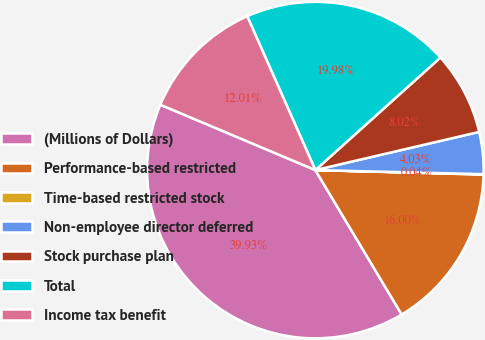<chart> <loc_0><loc_0><loc_500><loc_500><pie_chart><fcel>(Millions of Dollars)<fcel>Performance-based restricted<fcel>Time-based restricted stock<fcel>Non-employee director deferred<fcel>Stock purchase plan<fcel>Total<fcel>Income tax benefit<nl><fcel>39.93%<fcel>16.0%<fcel>0.04%<fcel>4.03%<fcel>8.02%<fcel>19.98%<fcel>12.01%<nl></chart> 